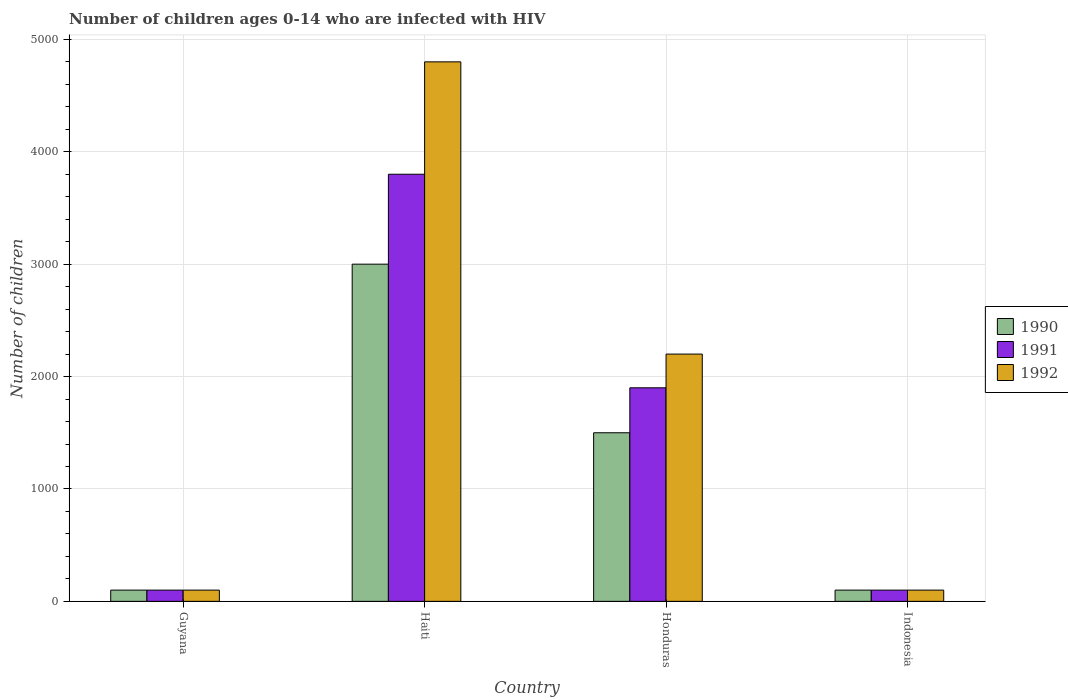How many different coloured bars are there?
Keep it short and to the point. 3. Are the number of bars on each tick of the X-axis equal?
Offer a terse response. Yes. How many bars are there on the 4th tick from the left?
Your response must be concise. 3. How many bars are there on the 3rd tick from the right?
Keep it short and to the point. 3. In how many cases, is the number of bars for a given country not equal to the number of legend labels?
Keep it short and to the point. 0. What is the number of HIV infected children in 1992 in Honduras?
Ensure brevity in your answer.  2200. Across all countries, what is the maximum number of HIV infected children in 1991?
Keep it short and to the point. 3800. Across all countries, what is the minimum number of HIV infected children in 1991?
Provide a short and direct response. 100. In which country was the number of HIV infected children in 1992 maximum?
Provide a succinct answer. Haiti. In which country was the number of HIV infected children in 1992 minimum?
Provide a short and direct response. Guyana. What is the total number of HIV infected children in 1991 in the graph?
Keep it short and to the point. 5900. What is the difference between the number of HIV infected children in 1992 in Honduras and that in Indonesia?
Give a very brief answer. 2100. What is the difference between the number of HIV infected children in 1991 in Haiti and the number of HIV infected children in 1992 in Guyana?
Your response must be concise. 3700. What is the average number of HIV infected children in 1991 per country?
Your answer should be compact. 1475. What is the difference between the number of HIV infected children of/in 1991 and number of HIV infected children of/in 1990 in Honduras?
Make the answer very short. 400. In how many countries, is the number of HIV infected children in 1991 greater than 2600?
Your answer should be compact. 1. What is the ratio of the number of HIV infected children in 1991 in Guyana to that in Honduras?
Offer a terse response. 0.05. Is the number of HIV infected children in 1991 in Guyana less than that in Haiti?
Keep it short and to the point. Yes. What is the difference between the highest and the second highest number of HIV infected children in 1992?
Give a very brief answer. 4700. What is the difference between the highest and the lowest number of HIV infected children in 1992?
Keep it short and to the point. 4700. In how many countries, is the number of HIV infected children in 1990 greater than the average number of HIV infected children in 1990 taken over all countries?
Your answer should be very brief. 2. What does the 2nd bar from the right in Indonesia represents?
Make the answer very short. 1991. How many bars are there?
Provide a succinct answer. 12. How many countries are there in the graph?
Provide a short and direct response. 4. What is the difference between two consecutive major ticks on the Y-axis?
Your answer should be compact. 1000. How many legend labels are there?
Provide a short and direct response. 3. What is the title of the graph?
Your answer should be compact. Number of children ages 0-14 who are infected with HIV. Does "1985" appear as one of the legend labels in the graph?
Give a very brief answer. No. What is the label or title of the X-axis?
Provide a succinct answer. Country. What is the label or title of the Y-axis?
Offer a very short reply. Number of children. What is the Number of children in 1990 in Haiti?
Ensure brevity in your answer.  3000. What is the Number of children in 1991 in Haiti?
Provide a succinct answer. 3800. What is the Number of children in 1992 in Haiti?
Provide a short and direct response. 4800. What is the Number of children of 1990 in Honduras?
Offer a terse response. 1500. What is the Number of children in 1991 in Honduras?
Ensure brevity in your answer.  1900. What is the Number of children in 1992 in Honduras?
Provide a short and direct response. 2200. What is the Number of children in 1991 in Indonesia?
Make the answer very short. 100. Across all countries, what is the maximum Number of children in 1990?
Ensure brevity in your answer.  3000. Across all countries, what is the maximum Number of children in 1991?
Make the answer very short. 3800. Across all countries, what is the maximum Number of children in 1992?
Your answer should be very brief. 4800. Across all countries, what is the minimum Number of children in 1990?
Offer a very short reply. 100. What is the total Number of children of 1990 in the graph?
Offer a terse response. 4700. What is the total Number of children of 1991 in the graph?
Your answer should be very brief. 5900. What is the total Number of children of 1992 in the graph?
Offer a terse response. 7200. What is the difference between the Number of children in 1990 in Guyana and that in Haiti?
Offer a terse response. -2900. What is the difference between the Number of children of 1991 in Guyana and that in Haiti?
Ensure brevity in your answer.  -3700. What is the difference between the Number of children of 1992 in Guyana and that in Haiti?
Your answer should be very brief. -4700. What is the difference between the Number of children of 1990 in Guyana and that in Honduras?
Offer a very short reply. -1400. What is the difference between the Number of children in 1991 in Guyana and that in Honduras?
Your answer should be compact. -1800. What is the difference between the Number of children of 1992 in Guyana and that in Honduras?
Give a very brief answer. -2100. What is the difference between the Number of children of 1990 in Haiti and that in Honduras?
Ensure brevity in your answer.  1500. What is the difference between the Number of children in 1991 in Haiti and that in Honduras?
Your answer should be very brief. 1900. What is the difference between the Number of children of 1992 in Haiti and that in Honduras?
Your answer should be compact. 2600. What is the difference between the Number of children of 1990 in Haiti and that in Indonesia?
Provide a succinct answer. 2900. What is the difference between the Number of children of 1991 in Haiti and that in Indonesia?
Ensure brevity in your answer.  3700. What is the difference between the Number of children in 1992 in Haiti and that in Indonesia?
Your answer should be compact. 4700. What is the difference between the Number of children in 1990 in Honduras and that in Indonesia?
Ensure brevity in your answer.  1400. What is the difference between the Number of children in 1991 in Honduras and that in Indonesia?
Offer a terse response. 1800. What is the difference between the Number of children of 1992 in Honduras and that in Indonesia?
Your response must be concise. 2100. What is the difference between the Number of children in 1990 in Guyana and the Number of children in 1991 in Haiti?
Ensure brevity in your answer.  -3700. What is the difference between the Number of children in 1990 in Guyana and the Number of children in 1992 in Haiti?
Your response must be concise. -4700. What is the difference between the Number of children of 1991 in Guyana and the Number of children of 1992 in Haiti?
Ensure brevity in your answer.  -4700. What is the difference between the Number of children of 1990 in Guyana and the Number of children of 1991 in Honduras?
Your response must be concise. -1800. What is the difference between the Number of children in 1990 in Guyana and the Number of children in 1992 in Honduras?
Offer a terse response. -2100. What is the difference between the Number of children of 1991 in Guyana and the Number of children of 1992 in Honduras?
Make the answer very short. -2100. What is the difference between the Number of children of 1991 in Guyana and the Number of children of 1992 in Indonesia?
Make the answer very short. 0. What is the difference between the Number of children in 1990 in Haiti and the Number of children in 1991 in Honduras?
Your answer should be compact. 1100. What is the difference between the Number of children of 1990 in Haiti and the Number of children of 1992 in Honduras?
Keep it short and to the point. 800. What is the difference between the Number of children in 1991 in Haiti and the Number of children in 1992 in Honduras?
Provide a short and direct response. 1600. What is the difference between the Number of children in 1990 in Haiti and the Number of children in 1991 in Indonesia?
Provide a short and direct response. 2900. What is the difference between the Number of children of 1990 in Haiti and the Number of children of 1992 in Indonesia?
Make the answer very short. 2900. What is the difference between the Number of children in 1991 in Haiti and the Number of children in 1992 in Indonesia?
Ensure brevity in your answer.  3700. What is the difference between the Number of children of 1990 in Honduras and the Number of children of 1991 in Indonesia?
Your response must be concise. 1400. What is the difference between the Number of children in 1990 in Honduras and the Number of children in 1992 in Indonesia?
Ensure brevity in your answer.  1400. What is the difference between the Number of children in 1991 in Honduras and the Number of children in 1992 in Indonesia?
Provide a short and direct response. 1800. What is the average Number of children of 1990 per country?
Your answer should be very brief. 1175. What is the average Number of children in 1991 per country?
Your answer should be compact. 1475. What is the average Number of children of 1992 per country?
Your response must be concise. 1800. What is the difference between the Number of children in 1990 and Number of children in 1992 in Guyana?
Your answer should be compact. 0. What is the difference between the Number of children in 1991 and Number of children in 1992 in Guyana?
Keep it short and to the point. 0. What is the difference between the Number of children in 1990 and Number of children in 1991 in Haiti?
Provide a succinct answer. -800. What is the difference between the Number of children of 1990 and Number of children of 1992 in Haiti?
Offer a very short reply. -1800. What is the difference between the Number of children in 1991 and Number of children in 1992 in Haiti?
Your response must be concise. -1000. What is the difference between the Number of children of 1990 and Number of children of 1991 in Honduras?
Your response must be concise. -400. What is the difference between the Number of children in 1990 and Number of children in 1992 in Honduras?
Your response must be concise. -700. What is the difference between the Number of children in 1991 and Number of children in 1992 in Honduras?
Keep it short and to the point. -300. What is the difference between the Number of children of 1991 and Number of children of 1992 in Indonesia?
Ensure brevity in your answer.  0. What is the ratio of the Number of children in 1991 in Guyana to that in Haiti?
Your answer should be compact. 0.03. What is the ratio of the Number of children of 1992 in Guyana to that in Haiti?
Give a very brief answer. 0.02. What is the ratio of the Number of children of 1990 in Guyana to that in Honduras?
Provide a short and direct response. 0.07. What is the ratio of the Number of children of 1991 in Guyana to that in Honduras?
Your answer should be very brief. 0.05. What is the ratio of the Number of children of 1992 in Guyana to that in Honduras?
Your answer should be compact. 0.05. What is the ratio of the Number of children of 1990 in Guyana to that in Indonesia?
Make the answer very short. 1. What is the ratio of the Number of children in 1991 in Guyana to that in Indonesia?
Make the answer very short. 1. What is the ratio of the Number of children in 1992 in Guyana to that in Indonesia?
Offer a very short reply. 1. What is the ratio of the Number of children of 1991 in Haiti to that in Honduras?
Offer a terse response. 2. What is the ratio of the Number of children in 1992 in Haiti to that in Honduras?
Provide a succinct answer. 2.18. What is the ratio of the Number of children in 1990 in Haiti to that in Indonesia?
Provide a succinct answer. 30. What is the ratio of the Number of children of 1991 in Haiti to that in Indonesia?
Ensure brevity in your answer.  38. What is the ratio of the Number of children of 1992 in Haiti to that in Indonesia?
Ensure brevity in your answer.  48. What is the difference between the highest and the second highest Number of children in 1990?
Give a very brief answer. 1500. What is the difference between the highest and the second highest Number of children of 1991?
Offer a very short reply. 1900. What is the difference between the highest and the second highest Number of children in 1992?
Your response must be concise. 2600. What is the difference between the highest and the lowest Number of children in 1990?
Your answer should be very brief. 2900. What is the difference between the highest and the lowest Number of children in 1991?
Offer a very short reply. 3700. What is the difference between the highest and the lowest Number of children of 1992?
Your answer should be very brief. 4700. 